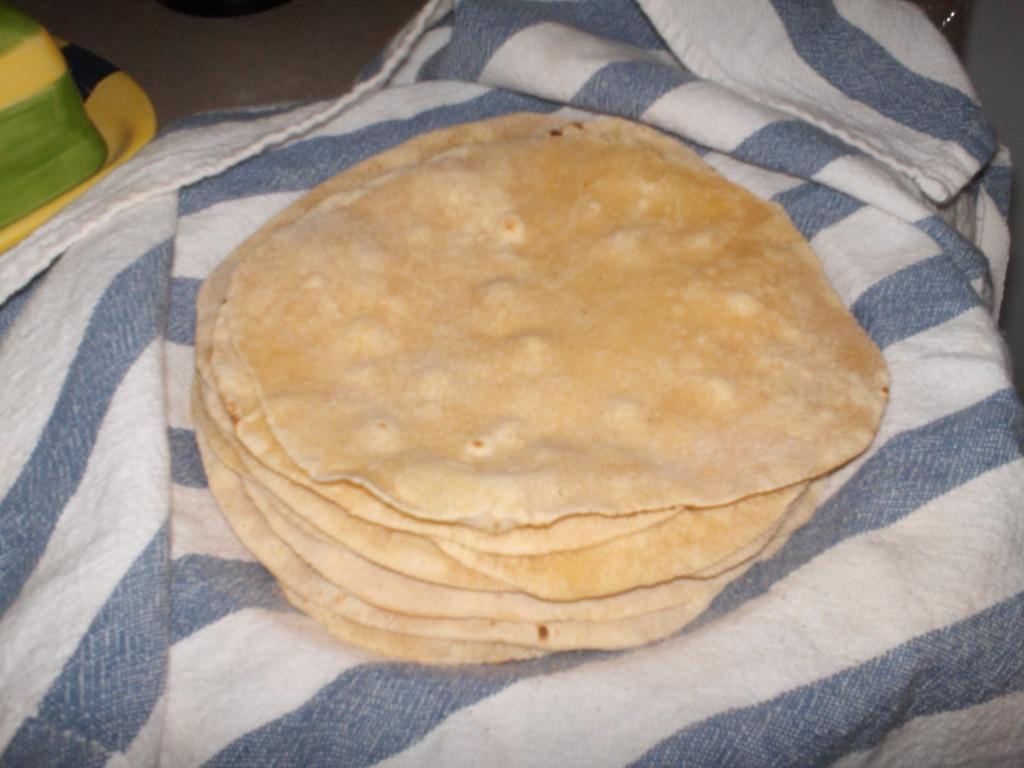In one or two sentences, can you explain what this image depicts? In this image we can see some loaves of flat bread on a cloth. At the top left we can see an object. 